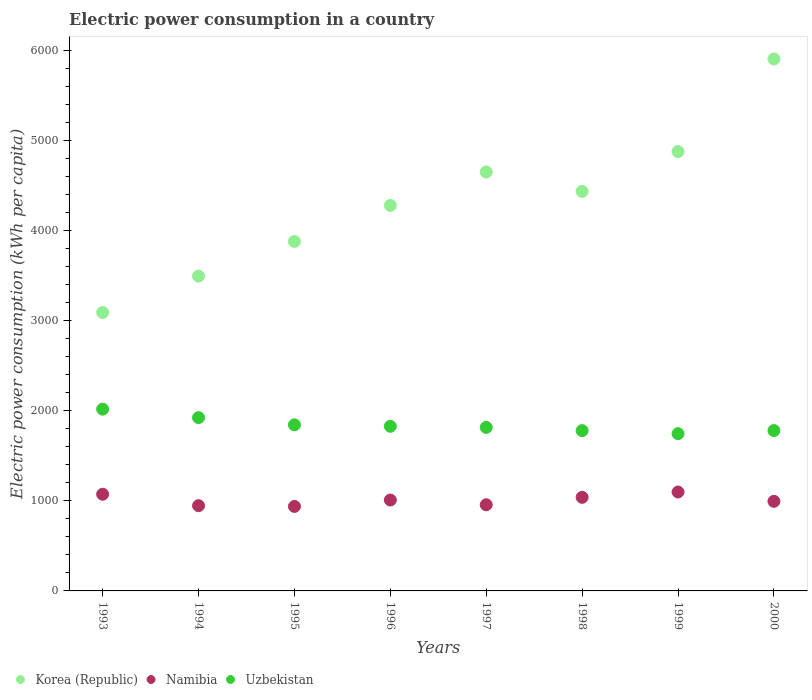Is the number of dotlines equal to the number of legend labels?
Offer a very short reply. Yes. What is the electric power consumption in in Namibia in 1997?
Ensure brevity in your answer.  956.72. Across all years, what is the maximum electric power consumption in in Korea (Republic)?
Provide a short and direct response. 5906.96. Across all years, what is the minimum electric power consumption in in Namibia?
Your response must be concise. 938.21. What is the total electric power consumption in in Namibia in the graph?
Offer a terse response. 8056.48. What is the difference between the electric power consumption in in Korea (Republic) in 1994 and that in 1998?
Your answer should be very brief. -940.69. What is the difference between the electric power consumption in in Uzbekistan in 1994 and the electric power consumption in in Namibia in 1999?
Provide a succinct answer. 826.12. What is the average electric power consumption in in Namibia per year?
Make the answer very short. 1007.06. In the year 1998, what is the difference between the electric power consumption in in Namibia and electric power consumption in in Korea (Republic)?
Make the answer very short. -3396.9. In how many years, is the electric power consumption in in Namibia greater than 600 kWh per capita?
Keep it short and to the point. 8. What is the ratio of the electric power consumption in in Uzbekistan in 1998 to that in 1999?
Your response must be concise. 1.02. What is the difference between the highest and the second highest electric power consumption in in Korea (Republic)?
Provide a short and direct response. 1028.13. What is the difference between the highest and the lowest electric power consumption in in Namibia?
Give a very brief answer. 160.15. In how many years, is the electric power consumption in in Uzbekistan greater than the average electric power consumption in in Uzbekistan taken over all years?
Keep it short and to the point. 3. Is the sum of the electric power consumption in in Uzbekistan in 1993 and 1998 greater than the maximum electric power consumption in in Namibia across all years?
Offer a very short reply. Yes. Is the electric power consumption in in Korea (Republic) strictly greater than the electric power consumption in in Namibia over the years?
Offer a very short reply. Yes. How many dotlines are there?
Your answer should be compact. 3. Where does the legend appear in the graph?
Your answer should be compact. Bottom left. How are the legend labels stacked?
Offer a terse response. Horizontal. What is the title of the graph?
Provide a short and direct response. Electric power consumption in a country. What is the label or title of the Y-axis?
Make the answer very short. Electric power consumption (kWh per capita). What is the Electric power consumption (kWh per capita) in Korea (Republic) in 1993?
Give a very brief answer. 3091.37. What is the Electric power consumption (kWh per capita) in Namibia in 1993?
Make the answer very short. 1073.43. What is the Electric power consumption (kWh per capita) in Uzbekistan in 1993?
Make the answer very short. 2018.23. What is the Electric power consumption (kWh per capita) in Korea (Republic) in 1994?
Your answer should be compact. 3495.49. What is the Electric power consumption (kWh per capita) in Namibia in 1994?
Your answer should be compact. 946.55. What is the Electric power consumption (kWh per capita) in Uzbekistan in 1994?
Make the answer very short. 1924.48. What is the Electric power consumption (kWh per capita) in Korea (Republic) in 1995?
Give a very brief answer. 3881.02. What is the Electric power consumption (kWh per capita) in Namibia in 1995?
Provide a short and direct response. 938.21. What is the Electric power consumption (kWh per capita) of Uzbekistan in 1995?
Offer a terse response. 1844.2. What is the Electric power consumption (kWh per capita) of Korea (Republic) in 1996?
Give a very brief answer. 4280.71. What is the Electric power consumption (kWh per capita) of Namibia in 1996?
Offer a terse response. 1009.18. What is the Electric power consumption (kWh per capita) of Uzbekistan in 1996?
Offer a very short reply. 1827.77. What is the Electric power consumption (kWh per capita) in Korea (Republic) in 1997?
Give a very brief answer. 4651.63. What is the Electric power consumption (kWh per capita) in Namibia in 1997?
Your response must be concise. 956.72. What is the Electric power consumption (kWh per capita) of Uzbekistan in 1997?
Provide a succinct answer. 1815.82. What is the Electric power consumption (kWh per capita) of Korea (Republic) in 1998?
Ensure brevity in your answer.  4436.17. What is the Electric power consumption (kWh per capita) of Namibia in 1998?
Provide a succinct answer. 1039.27. What is the Electric power consumption (kWh per capita) in Uzbekistan in 1998?
Make the answer very short. 1779.88. What is the Electric power consumption (kWh per capita) in Korea (Republic) in 1999?
Offer a terse response. 4878.83. What is the Electric power consumption (kWh per capita) in Namibia in 1999?
Keep it short and to the point. 1098.36. What is the Electric power consumption (kWh per capita) of Uzbekistan in 1999?
Keep it short and to the point. 1745.95. What is the Electric power consumption (kWh per capita) of Korea (Republic) in 2000?
Offer a terse response. 5906.96. What is the Electric power consumption (kWh per capita) of Namibia in 2000?
Offer a terse response. 994.76. What is the Electric power consumption (kWh per capita) in Uzbekistan in 2000?
Ensure brevity in your answer.  1780.46. Across all years, what is the maximum Electric power consumption (kWh per capita) in Korea (Republic)?
Make the answer very short. 5906.96. Across all years, what is the maximum Electric power consumption (kWh per capita) in Namibia?
Offer a very short reply. 1098.36. Across all years, what is the maximum Electric power consumption (kWh per capita) in Uzbekistan?
Offer a very short reply. 2018.23. Across all years, what is the minimum Electric power consumption (kWh per capita) in Korea (Republic)?
Your response must be concise. 3091.37. Across all years, what is the minimum Electric power consumption (kWh per capita) in Namibia?
Make the answer very short. 938.21. Across all years, what is the minimum Electric power consumption (kWh per capita) in Uzbekistan?
Your response must be concise. 1745.95. What is the total Electric power consumption (kWh per capita) in Korea (Republic) in the graph?
Provide a short and direct response. 3.46e+04. What is the total Electric power consumption (kWh per capita) of Namibia in the graph?
Give a very brief answer. 8056.48. What is the total Electric power consumption (kWh per capita) of Uzbekistan in the graph?
Your response must be concise. 1.47e+04. What is the difference between the Electric power consumption (kWh per capita) in Korea (Republic) in 1993 and that in 1994?
Your response must be concise. -404.12. What is the difference between the Electric power consumption (kWh per capita) in Namibia in 1993 and that in 1994?
Offer a terse response. 126.88. What is the difference between the Electric power consumption (kWh per capita) of Uzbekistan in 1993 and that in 1994?
Give a very brief answer. 93.75. What is the difference between the Electric power consumption (kWh per capita) of Korea (Republic) in 1993 and that in 1995?
Your answer should be very brief. -789.65. What is the difference between the Electric power consumption (kWh per capita) in Namibia in 1993 and that in 1995?
Offer a terse response. 135.22. What is the difference between the Electric power consumption (kWh per capita) in Uzbekistan in 1993 and that in 1995?
Make the answer very short. 174.03. What is the difference between the Electric power consumption (kWh per capita) in Korea (Republic) in 1993 and that in 1996?
Offer a terse response. -1189.34. What is the difference between the Electric power consumption (kWh per capita) in Namibia in 1993 and that in 1996?
Offer a very short reply. 64.26. What is the difference between the Electric power consumption (kWh per capita) of Uzbekistan in 1993 and that in 1996?
Offer a very short reply. 190.46. What is the difference between the Electric power consumption (kWh per capita) of Korea (Republic) in 1993 and that in 1997?
Provide a succinct answer. -1560.26. What is the difference between the Electric power consumption (kWh per capita) in Namibia in 1993 and that in 1997?
Offer a terse response. 116.72. What is the difference between the Electric power consumption (kWh per capita) of Uzbekistan in 1993 and that in 1997?
Your answer should be compact. 202.41. What is the difference between the Electric power consumption (kWh per capita) of Korea (Republic) in 1993 and that in 1998?
Your response must be concise. -1344.8. What is the difference between the Electric power consumption (kWh per capita) in Namibia in 1993 and that in 1998?
Provide a short and direct response. 34.16. What is the difference between the Electric power consumption (kWh per capita) of Uzbekistan in 1993 and that in 1998?
Provide a succinct answer. 238.35. What is the difference between the Electric power consumption (kWh per capita) in Korea (Republic) in 1993 and that in 1999?
Give a very brief answer. -1787.46. What is the difference between the Electric power consumption (kWh per capita) in Namibia in 1993 and that in 1999?
Provide a short and direct response. -24.92. What is the difference between the Electric power consumption (kWh per capita) of Uzbekistan in 1993 and that in 1999?
Ensure brevity in your answer.  272.28. What is the difference between the Electric power consumption (kWh per capita) of Korea (Republic) in 1993 and that in 2000?
Provide a short and direct response. -2815.59. What is the difference between the Electric power consumption (kWh per capita) in Namibia in 1993 and that in 2000?
Make the answer very short. 78.68. What is the difference between the Electric power consumption (kWh per capita) in Uzbekistan in 1993 and that in 2000?
Ensure brevity in your answer.  237.77. What is the difference between the Electric power consumption (kWh per capita) in Korea (Republic) in 1994 and that in 1995?
Offer a terse response. -385.54. What is the difference between the Electric power consumption (kWh per capita) of Namibia in 1994 and that in 1995?
Give a very brief answer. 8.34. What is the difference between the Electric power consumption (kWh per capita) of Uzbekistan in 1994 and that in 1995?
Give a very brief answer. 80.28. What is the difference between the Electric power consumption (kWh per capita) in Korea (Republic) in 1994 and that in 1996?
Your response must be concise. -785.22. What is the difference between the Electric power consumption (kWh per capita) of Namibia in 1994 and that in 1996?
Your answer should be compact. -62.63. What is the difference between the Electric power consumption (kWh per capita) of Uzbekistan in 1994 and that in 1996?
Your answer should be very brief. 96.7. What is the difference between the Electric power consumption (kWh per capita) of Korea (Republic) in 1994 and that in 1997?
Ensure brevity in your answer.  -1156.14. What is the difference between the Electric power consumption (kWh per capita) of Namibia in 1994 and that in 1997?
Make the answer very short. -10.16. What is the difference between the Electric power consumption (kWh per capita) in Uzbekistan in 1994 and that in 1997?
Make the answer very short. 108.66. What is the difference between the Electric power consumption (kWh per capita) of Korea (Republic) in 1994 and that in 1998?
Keep it short and to the point. -940.69. What is the difference between the Electric power consumption (kWh per capita) of Namibia in 1994 and that in 1998?
Offer a very short reply. -92.72. What is the difference between the Electric power consumption (kWh per capita) in Uzbekistan in 1994 and that in 1998?
Give a very brief answer. 144.59. What is the difference between the Electric power consumption (kWh per capita) of Korea (Republic) in 1994 and that in 1999?
Offer a very short reply. -1383.34. What is the difference between the Electric power consumption (kWh per capita) in Namibia in 1994 and that in 1999?
Your response must be concise. -151.8. What is the difference between the Electric power consumption (kWh per capita) in Uzbekistan in 1994 and that in 1999?
Provide a short and direct response. 178.52. What is the difference between the Electric power consumption (kWh per capita) in Korea (Republic) in 1994 and that in 2000?
Give a very brief answer. -2411.47. What is the difference between the Electric power consumption (kWh per capita) of Namibia in 1994 and that in 2000?
Give a very brief answer. -48.2. What is the difference between the Electric power consumption (kWh per capita) of Uzbekistan in 1994 and that in 2000?
Offer a terse response. 144.02. What is the difference between the Electric power consumption (kWh per capita) of Korea (Republic) in 1995 and that in 1996?
Your response must be concise. -399.69. What is the difference between the Electric power consumption (kWh per capita) of Namibia in 1995 and that in 1996?
Your response must be concise. -70.97. What is the difference between the Electric power consumption (kWh per capita) in Uzbekistan in 1995 and that in 1996?
Your answer should be very brief. 16.42. What is the difference between the Electric power consumption (kWh per capita) in Korea (Republic) in 1995 and that in 1997?
Provide a short and direct response. -770.6. What is the difference between the Electric power consumption (kWh per capita) of Namibia in 1995 and that in 1997?
Your answer should be compact. -18.51. What is the difference between the Electric power consumption (kWh per capita) in Uzbekistan in 1995 and that in 1997?
Offer a terse response. 28.38. What is the difference between the Electric power consumption (kWh per capita) in Korea (Republic) in 1995 and that in 1998?
Make the answer very short. -555.15. What is the difference between the Electric power consumption (kWh per capita) in Namibia in 1995 and that in 1998?
Your answer should be very brief. -101.06. What is the difference between the Electric power consumption (kWh per capita) in Uzbekistan in 1995 and that in 1998?
Give a very brief answer. 64.31. What is the difference between the Electric power consumption (kWh per capita) in Korea (Republic) in 1995 and that in 1999?
Offer a terse response. -997.81. What is the difference between the Electric power consumption (kWh per capita) in Namibia in 1995 and that in 1999?
Provide a short and direct response. -160.15. What is the difference between the Electric power consumption (kWh per capita) in Uzbekistan in 1995 and that in 1999?
Offer a terse response. 98.24. What is the difference between the Electric power consumption (kWh per capita) in Korea (Republic) in 1995 and that in 2000?
Offer a terse response. -2025.93. What is the difference between the Electric power consumption (kWh per capita) in Namibia in 1995 and that in 2000?
Provide a short and direct response. -56.55. What is the difference between the Electric power consumption (kWh per capita) of Uzbekistan in 1995 and that in 2000?
Ensure brevity in your answer.  63.74. What is the difference between the Electric power consumption (kWh per capita) in Korea (Republic) in 1996 and that in 1997?
Ensure brevity in your answer.  -370.92. What is the difference between the Electric power consumption (kWh per capita) in Namibia in 1996 and that in 1997?
Ensure brevity in your answer.  52.46. What is the difference between the Electric power consumption (kWh per capita) of Uzbekistan in 1996 and that in 1997?
Offer a terse response. 11.95. What is the difference between the Electric power consumption (kWh per capita) of Korea (Republic) in 1996 and that in 1998?
Give a very brief answer. -155.46. What is the difference between the Electric power consumption (kWh per capita) in Namibia in 1996 and that in 1998?
Make the answer very short. -30.09. What is the difference between the Electric power consumption (kWh per capita) of Uzbekistan in 1996 and that in 1998?
Make the answer very short. 47.89. What is the difference between the Electric power consumption (kWh per capita) of Korea (Republic) in 1996 and that in 1999?
Your answer should be compact. -598.12. What is the difference between the Electric power consumption (kWh per capita) of Namibia in 1996 and that in 1999?
Your answer should be very brief. -89.18. What is the difference between the Electric power consumption (kWh per capita) of Uzbekistan in 1996 and that in 1999?
Give a very brief answer. 81.82. What is the difference between the Electric power consumption (kWh per capita) in Korea (Republic) in 1996 and that in 2000?
Give a very brief answer. -1626.25. What is the difference between the Electric power consumption (kWh per capita) in Namibia in 1996 and that in 2000?
Your response must be concise. 14.42. What is the difference between the Electric power consumption (kWh per capita) of Uzbekistan in 1996 and that in 2000?
Provide a short and direct response. 47.31. What is the difference between the Electric power consumption (kWh per capita) in Korea (Republic) in 1997 and that in 1998?
Provide a short and direct response. 215.45. What is the difference between the Electric power consumption (kWh per capita) of Namibia in 1997 and that in 1998?
Offer a very short reply. -82.56. What is the difference between the Electric power consumption (kWh per capita) of Uzbekistan in 1997 and that in 1998?
Ensure brevity in your answer.  35.94. What is the difference between the Electric power consumption (kWh per capita) in Korea (Republic) in 1997 and that in 1999?
Offer a very short reply. -227.2. What is the difference between the Electric power consumption (kWh per capita) in Namibia in 1997 and that in 1999?
Your answer should be compact. -141.64. What is the difference between the Electric power consumption (kWh per capita) in Uzbekistan in 1997 and that in 1999?
Provide a succinct answer. 69.87. What is the difference between the Electric power consumption (kWh per capita) in Korea (Republic) in 1997 and that in 2000?
Provide a short and direct response. -1255.33. What is the difference between the Electric power consumption (kWh per capita) in Namibia in 1997 and that in 2000?
Ensure brevity in your answer.  -38.04. What is the difference between the Electric power consumption (kWh per capita) of Uzbekistan in 1997 and that in 2000?
Provide a succinct answer. 35.36. What is the difference between the Electric power consumption (kWh per capita) in Korea (Republic) in 1998 and that in 1999?
Give a very brief answer. -442.66. What is the difference between the Electric power consumption (kWh per capita) of Namibia in 1998 and that in 1999?
Your answer should be very brief. -59.08. What is the difference between the Electric power consumption (kWh per capita) in Uzbekistan in 1998 and that in 1999?
Ensure brevity in your answer.  33.93. What is the difference between the Electric power consumption (kWh per capita) in Korea (Republic) in 1998 and that in 2000?
Provide a succinct answer. -1470.78. What is the difference between the Electric power consumption (kWh per capita) of Namibia in 1998 and that in 2000?
Your answer should be compact. 44.52. What is the difference between the Electric power consumption (kWh per capita) in Uzbekistan in 1998 and that in 2000?
Provide a succinct answer. -0.57. What is the difference between the Electric power consumption (kWh per capita) of Korea (Republic) in 1999 and that in 2000?
Make the answer very short. -1028.13. What is the difference between the Electric power consumption (kWh per capita) in Namibia in 1999 and that in 2000?
Offer a very short reply. 103.6. What is the difference between the Electric power consumption (kWh per capita) of Uzbekistan in 1999 and that in 2000?
Offer a very short reply. -34.5. What is the difference between the Electric power consumption (kWh per capita) of Korea (Republic) in 1993 and the Electric power consumption (kWh per capita) of Namibia in 1994?
Make the answer very short. 2144.82. What is the difference between the Electric power consumption (kWh per capita) in Korea (Republic) in 1993 and the Electric power consumption (kWh per capita) in Uzbekistan in 1994?
Make the answer very short. 1166.9. What is the difference between the Electric power consumption (kWh per capita) of Namibia in 1993 and the Electric power consumption (kWh per capita) of Uzbekistan in 1994?
Your answer should be compact. -851.04. What is the difference between the Electric power consumption (kWh per capita) in Korea (Republic) in 1993 and the Electric power consumption (kWh per capita) in Namibia in 1995?
Ensure brevity in your answer.  2153.16. What is the difference between the Electric power consumption (kWh per capita) in Korea (Republic) in 1993 and the Electric power consumption (kWh per capita) in Uzbekistan in 1995?
Your answer should be very brief. 1247.18. What is the difference between the Electric power consumption (kWh per capita) of Namibia in 1993 and the Electric power consumption (kWh per capita) of Uzbekistan in 1995?
Your answer should be compact. -770.76. What is the difference between the Electric power consumption (kWh per capita) of Korea (Republic) in 1993 and the Electric power consumption (kWh per capita) of Namibia in 1996?
Your answer should be very brief. 2082.19. What is the difference between the Electric power consumption (kWh per capita) in Korea (Republic) in 1993 and the Electric power consumption (kWh per capita) in Uzbekistan in 1996?
Keep it short and to the point. 1263.6. What is the difference between the Electric power consumption (kWh per capita) in Namibia in 1993 and the Electric power consumption (kWh per capita) in Uzbekistan in 1996?
Your answer should be very brief. -754.34. What is the difference between the Electric power consumption (kWh per capita) of Korea (Republic) in 1993 and the Electric power consumption (kWh per capita) of Namibia in 1997?
Keep it short and to the point. 2134.65. What is the difference between the Electric power consumption (kWh per capita) in Korea (Republic) in 1993 and the Electric power consumption (kWh per capita) in Uzbekistan in 1997?
Make the answer very short. 1275.55. What is the difference between the Electric power consumption (kWh per capita) in Namibia in 1993 and the Electric power consumption (kWh per capita) in Uzbekistan in 1997?
Offer a very short reply. -742.38. What is the difference between the Electric power consumption (kWh per capita) in Korea (Republic) in 1993 and the Electric power consumption (kWh per capita) in Namibia in 1998?
Make the answer very short. 2052.1. What is the difference between the Electric power consumption (kWh per capita) in Korea (Republic) in 1993 and the Electric power consumption (kWh per capita) in Uzbekistan in 1998?
Your answer should be very brief. 1311.49. What is the difference between the Electric power consumption (kWh per capita) in Namibia in 1993 and the Electric power consumption (kWh per capita) in Uzbekistan in 1998?
Make the answer very short. -706.45. What is the difference between the Electric power consumption (kWh per capita) of Korea (Republic) in 1993 and the Electric power consumption (kWh per capita) of Namibia in 1999?
Ensure brevity in your answer.  1993.01. What is the difference between the Electric power consumption (kWh per capita) of Korea (Republic) in 1993 and the Electric power consumption (kWh per capita) of Uzbekistan in 1999?
Your answer should be very brief. 1345.42. What is the difference between the Electric power consumption (kWh per capita) of Namibia in 1993 and the Electric power consumption (kWh per capita) of Uzbekistan in 1999?
Offer a terse response. -672.52. What is the difference between the Electric power consumption (kWh per capita) of Korea (Republic) in 1993 and the Electric power consumption (kWh per capita) of Namibia in 2000?
Make the answer very short. 2096.62. What is the difference between the Electric power consumption (kWh per capita) in Korea (Republic) in 1993 and the Electric power consumption (kWh per capita) in Uzbekistan in 2000?
Provide a succinct answer. 1310.91. What is the difference between the Electric power consumption (kWh per capita) in Namibia in 1993 and the Electric power consumption (kWh per capita) in Uzbekistan in 2000?
Offer a terse response. -707.02. What is the difference between the Electric power consumption (kWh per capita) in Korea (Republic) in 1994 and the Electric power consumption (kWh per capita) in Namibia in 1995?
Provide a short and direct response. 2557.28. What is the difference between the Electric power consumption (kWh per capita) in Korea (Republic) in 1994 and the Electric power consumption (kWh per capita) in Uzbekistan in 1995?
Make the answer very short. 1651.29. What is the difference between the Electric power consumption (kWh per capita) of Namibia in 1994 and the Electric power consumption (kWh per capita) of Uzbekistan in 1995?
Ensure brevity in your answer.  -897.64. What is the difference between the Electric power consumption (kWh per capita) in Korea (Republic) in 1994 and the Electric power consumption (kWh per capita) in Namibia in 1996?
Give a very brief answer. 2486.31. What is the difference between the Electric power consumption (kWh per capita) of Korea (Republic) in 1994 and the Electric power consumption (kWh per capita) of Uzbekistan in 1996?
Your answer should be compact. 1667.72. What is the difference between the Electric power consumption (kWh per capita) in Namibia in 1994 and the Electric power consumption (kWh per capita) in Uzbekistan in 1996?
Your response must be concise. -881.22. What is the difference between the Electric power consumption (kWh per capita) of Korea (Republic) in 1994 and the Electric power consumption (kWh per capita) of Namibia in 1997?
Make the answer very short. 2538.77. What is the difference between the Electric power consumption (kWh per capita) in Korea (Republic) in 1994 and the Electric power consumption (kWh per capita) in Uzbekistan in 1997?
Keep it short and to the point. 1679.67. What is the difference between the Electric power consumption (kWh per capita) in Namibia in 1994 and the Electric power consumption (kWh per capita) in Uzbekistan in 1997?
Provide a short and direct response. -869.27. What is the difference between the Electric power consumption (kWh per capita) in Korea (Republic) in 1994 and the Electric power consumption (kWh per capita) in Namibia in 1998?
Give a very brief answer. 2456.22. What is the difference between the Electric power consumption (kWh per capita) in Korea (Republic) in 1994 and the Electric power consumption (kWh per capita) in Uzbekistan in 1998?
Ensure brevity in your answer.  1715.6. What is the difference between the Electric power consumption (kWh per capita) of Namibia in 1994 and the Electric power consumption (kWh per capita) of Uzbekistan in 1998?
Your response must be concise. -833.33. What is the difference between the Electric power consumption (kWh per capita) in Korea (Republic) in 1994 and the Electric power consumption (kWh per capita) in Namibia in 1999?
Make the answer very short. 2397.13. What is the difference between the Electric power consumption (kWh per capita) in Korea (Republic) in 1994 and the Electric power consumption (kWh per capita) in Uzbekistan in 1999?
Make the answer very short. 1749.54. What is the difference between the Electric power consumption (kWh per capita) in Namibia in 1994 and the Electric power consumption (kWh per capita) in Uzbekistan in 1999?
Make the answer very short. -799.4. What is the difference between the Electric power consumption (kWh per capita) of Korea (Republic) in 1994 and the Electric power consumption (kWh per capita) of Namibia in 2000?
Your response must be concise. 2500.73. What is the difference between the Electric power consumption (kWh per capita) of Korea (Republic) in 1994 and the Electric power consumption (kWh per capita) of Uzbekistan in 2000?
Your answer should be compact. 1715.03. What is the difference between the Electric power consumption (kWh per capita) of Namibia in 1994 and the Electric power consumption (kWh per capita) of Uzbekistan in 2000?
Your answer should be compact. -833.91. What is the difference between the Electric power consumption (kWh per capita) of Korea (Republic) in 1995 and the Electric power consumption (kWh per capita) of Namibia in 1996?
Your response must be concise. 2871.85. What is the difference between the Electric power consumption (kWh per capita) in Korea (Republic) in 1995 and the Electric power consumption (kWh per capita) in Uzbekistan in 1996?
Offer a very short reply. 2053.25. What is the difference between the Electric power consumption (kWh per capita) in Namibia in 1995 and the Electric power consumption (kWh per capita) in Uzbekistan in 1996?
Provide a short and direct response. -889.56. What is the difference between the Electric power consumption (kWh per capita) of Korea (Republic) in 1995 and the Electric power consumption (kWh per capita) of Namibia in 1997?
Offer a very short reply. 2924.31. What is the difference between the Electric power consumption (kWh per capita) in Korea (Republic) in 1995 and the Electric power consumption (kWh per capita) in Uzbekistan in 1997?
Provide a short and direct response. 2065.2. What is the difference between the Electric power consumption (kWh per capita) in Namibia in 1995 and the Electric power consumption (kWh per capita) in Uzbekistan in 1997?
Make the answer very short. -877.61. What is the difference between the Electric power consumption (kWh per capita) of Korea (Republic) in 1995 and the Electric power consumption (kWh per capita) of Namibia in 1998?
Provide a short and direct response. 2841.75. What is the difference between the Electric power consumption (kWh per capita) in Korea (Republic) in 1995 and the Electric power consumption (kWh per capita) in Uzbekistan in 1998?
Keep it short and to the point. 2101.14. What is the difference between the Electric power consumption (kWh per capita) in Namibia in 1995 and the Electric power consumption (kWh per capita) in Uzbekistan in 1998?
Provide a succinct answer. -841.67. What is the difference between the Electric power consumption (kWh per capita) in Korea (Republic) in 1995 and the Electric power consumption (kWh per capita) in Namibia in 1999?
Keep it short and to the point. 2782.67. What is the difference between the Electric power consumption (kWh per capita) in Korea (Republic) in 1995 and the Electric power consumption (kWh per capita) in Uzbekistan in 1999?
Keep it short and to the point. 2135.07. What is the difference between the Electric power consumption (kWh per capita) of Namibia in 1995 and the Electric power consumption (kWh per capita) of Uzbekistan in 1999?
Offer a very short reply. -807.74. What is the difference between the Electric power consumption (kWh per capita) in Korea (Republic) in 1995 and the Electric power consumption (kWh per capita) in Namibia in 2000?
Keep it short and to the point. 2886.27. What is the difference between the Electric power consumption (kWh per capita) in Korea (Republic) in 1995 and the Electric power consumption (kWh per capita) in Uzbekistan in 2000?
Offer a terse response. 2100.57. What is the difference between the Electric power consumption (kWh per capita) of Namibia in 1995 and the Electric power consumption (kWh per capita) of Uzbekistan in 2000?
Offer a terse response. -842.25. What is the difference between the Electric power consumption (kWh per capita) in Korea (Republic) in 1996 and the Electric power consumption (kWh per capita) in Namibia in 1997?
Make the answer very short. 3323.99. What is the difference between the Electric power consumption (kWh per capita) in Korea (Republic) in 1996 and the Electric power consumption (kWh per capita) in Uzbekistan in 1997?
Provide a short and direct response. 2464.89. What is the difference between the Electric power consumption (kWh per capita) in Namibia in 1996 and the Electric power consumption (kWh per capita) in Uzbekistan in 1997?
Keep it short and to the point. -806.64. What is the difference between the Electric power consumption (kWh per capita) of Korea (Republic) in 1996 and the Electric power consumption (kWh per capita) of Namibia in 1998?
Ensure brevity in your answer.  3241.44. What is the difference between the Electric power consumption (kWh per capita) of Korea (Republic) in 1996 and the Electric power consumption (kWh per capita) of Uzbekistan in 1998?
Offer a terse response. 2500.83. What is the difference between the Electric power consumption (kWh per capita) in Namibia in 1996 and the Electric power consumption (kWh per capita) in Uzbekistan in 1998?
Give a very brief answer. -770.71. What is the difference between the Electric power consumption (kWh per capita) in Korea (Republic) in 1996 and the Electric power consumption (kWh per capita) in Namibia in 1999?
Provide a short and direct response. 3182.35. What is the difference between the Electric power consumption (kWh per capita) in Korea (Republic) in 1996 and the Electric power consumption (kWh per capita) in Uzbekistan in 1999?
Give a very brief answer. 2534.76. What is the difference between the Electric power consumption (kWh per capita) in Namibia in 1996 and the Electric power consumption (kWh per capita) in Uzbekistan in 1999?
Make the answer very short. -736.78. What is the difference between the Electric power consumption (kWh per capita) of Korea (Republic) in 1996 and the Electric power consumption (kWh per capita) of Namibia in 2000?
Your answer should be compact. 3285.95. What is the difference between the Electric power consumption (kWh per capita) in Korea (Republic) in 1996 and the Electric power consumption (kWh per capita) in Uzbekistan in 2000?
Provide a short and direct response. 2500.25. What is the difference between the Electric power consumption (kWh per capita) of Namibia in 1996 and the Electric power consumption (kWh per capita) of Uzbekistan in 2000?
Offer a very short reply. -771.28. What is the difference between the Electric power consumption (kWh per capita) in Korea (Republic) in 1997 and the Electric power consumption (kWh per capita) in Namibia in 1998?
Make the answer very short. 3612.36. What is the difference between the Electric power consumption (kWh per capita) of Korea (Republic) in 1997 and the Electric power consumption (kWh per capita) of Uzbekistan in 1998?
Your answer should be compact. 2871.74. What is the difference between the Electric power consumption (kWh per capita) of Namibia in 1997 and the Electric power consumption (kWh per capita) of Uzbekistan in 1998?
Your answer should be compact. -823.17. What is the difference between the Electric power consumption (kWh per capita) of Korea (Republic) in 1997 and the Electric power consumption (kWh per capita) of Namibia in 1999?
Make the answer very short. 3553.27. What is the difference between the Electric power consumption (kWh per capita) in Korea (Republic) in 1997 and the Electric power consumption (kWh per capita) in Uzbekistan in 1999?
Your answer should be very brief. 2905.68. What is the difference between the Electric power consumption (kWh per capita) in Namibia in 1997 and the Electric power consumption (kWh per capita) in Uzbekistan in 1999?
Make the answer very short. -789.24. What is the difference between the Electric power consumption (kWh per capita) in Korea (Republic) in 1997 and the Electric power consumption (kWh per capita) in Namibia in 2000?
Make the answer very short. 3656.87. What is the difference between the Electric power consumption (kWh per capita) in Korea (Republic) in 1997 and the Electric power consumption (kWh per capita) in Uzbekistan in 2000?
Offer a very short reply. 2871.17. What is the difference between the Electric power consumption (kWh per capita) in Namibia in 1997 and the Electric power consumption (kWh per capita) in Uzbekistan in 2000?
Offer a very short reply. -823.74. What is the difference between the Electric power consumption (kWh per capita) of Korea (Republic) in 1998 and the Electric power consumption (kWh per capita) of Namibia in 1999?
Make the answer very short. 3337.82. What is the difference between the Electric power consumption (kWh per capita) in Korea (Republic) in 1998 and the Electric power consumption (kWh per capita) in Uzbekistan in 1999?
Make the answer very short. 2690.22. What is the difference between the Electric power consumption (kWh per capita) in Namibia in 1998 and the Electric power consumption (kWh per capita) in Uzbekistan in 1999?
Your answer should be very brief. -706.68. What is the difference between the Electric power consumption (kWh per capita) of Korea (Republic) in 1998 and the Electric power consumption (kWh per capita) of Namibia in 2000?
Ensure brevity in your answer.  3441.42. What is the difference between the Electric power consumption (kWh per capita) of Korea (Republic) in 1998 and the Electric power consumption (kWh per capita) of Uzbekistan in 2000?
Provide a short and direct response. 2655.72. What is the difference between the Electric power consumption (kWh per capita) in Namibia in 1998 and the Electric power consumption (kWh per capita) in Uzbekistan in 2000?
Offer a very short reply. -741.19. What is the difference between the Electric power consumption (kWh per capita) in Korea (Republic) in 1999 and the Electric power consumption (kWh per capita) in Namibia in 2000?
Offer a terse response. 3884.08. What is the difference between the Electric power consumption (kWh per capita) of Korea (Republic) in 1999 and the Electric power consumption (kWh per capita) of Uzbekistan in 2000?
Ensure brevity in your answer.  3098.38. What is the difference between the Electric power consumption (kWh per capita) in Namibia in 1999 and the Electric power consumption (kWh per capita) in Uzbekistan in 2000?
Offer a very short reply. -682.1. What is the average Electric power consumption (kWh per capita) in Korea (Republic) per year?
Ensure brevity in your answer.  4327.77. What is the average Electric power consumption (kWh per capita) of Namibia per year?
Offer a very short reply. 1007.06. What is the average Electric power consumption (kWh per capita) of Uzbekistan per year?
Offer a very short reply. 1842.1. In the year 1993, what is the difference between the Electric power consumption (kWh per capita) of Korea (Republic) and Electric power consumption (kWh per capita) of Namibia?
Provide a short and direct response. 2017.94. In the year 1993, what is the difference between the Electric power consumption (kWh per capita) in Korea (Republic) and Electric power consumption (kWh per capita) in Uzbekistan?
Make the answer very short. 1073.14. In the year 1993, what is the difference between the Electric power consumption (kWh per capita) of Namibia and Electric power consumption (kWh per capita) of Uzbekistan?
Give a very brief answer. -944.8. In the year 1994, what is the difference between the Electric power consumption (kWh per capita) in Korea (Republic) and Electric power consumption (kWh per capita) in Namibia?
Your answer should be very brief. 2548.94. In the year 1994, what is the difference between the Electric power consumption (kWh per capita) in Korea (Republic) and Electric power consumption (kWh per capita) in Uzbekistan?
Ensure brevity in your answer.  1571.01. In the year 1994, what is the difference between the Electric power consumption (kWh per capita) of Namibia and Electric power consumption (kWh per capita) of Uzbekistan?
Keep it short and to the point. -977.92. In the year 1995, what is the difference between the Electric power consumption (kWh per capita) of Korea (Republic) and Electric power consumption (kWh per capita) of Namibia?
Your answer should be compact. 2942.81. In the year 1995, what is the difference between the Electric power consumption (kWh per capita) in Korea (Republic) and Electric power consumption (kWh per capita) in Uzbekistan?
Provide a short and direct response. 2036.83. In the year 1995, what is the difference between the Electric power consumption (kWh per capita) of Namibia and Electric power consumption (kWh per capita) of Uzbekistan?
Your response must be concise. -905.99. In the year 1996, what is the difference between the Electric power consumption (kWh per capita) of Korea (Republic) and Electric power consumption (kWh per capita) of Namibia?
Provide a short and direct response. 3271.53. In the year 1996, what is the difference between the Electric power consumption (kWh per capita) in Korea (Republic) and Electric power consumption (kWh per capita) in Uzbekistan?
Provide a succinct answer. 2452.94. In the year 1996, what is the difference between the Electric power consumption (kWh per capita) of Namibia and Electric power consumption (kWh per capita) of Uzbekistan?
Give a very brief answer. -818.59. In the year 1997, what is the difference between the Electric power consumption (kWh per capita) of Korea (Republic) and Electric power consumption (kWh per capita) of Namibia?
Provide a succinct answer. 3694.91. In the year 1997, what is the difference between the Electric power consumption (kWh per capita) in Korea (Republic) and Electric power consumption (kWh per capita) in Uzbekistan?
Provide a short and direct response. 2835.81. In the year 1997, what is the difference between the Electric power consumption (kWh per capita) in Namibia and Electric power consumption (kWh per capita) in Uzbekistan?
Provide a short and direct response. -859.1. In the year 1998, what is the difference between the Electric power consumption (kWh per capita) of Korea (Republic) and Electric power consumption (kWh per capita) of Namibia?
Offer a very short reply. 3396.9. In the year 1998, what is the difference between the Electric power consumption (kWh per capita) of Korea (Republic) and Electric power consumption (kWh per capita) of Uzbekistan?
Your answer should be very brief. 2656.29. In the year 1998, what is the difference between the Electric power consumption (kWh per capita) of Namibia and Electric power consumption (kWh per capita) of Uzbekistan?
Ensure brevity in your answer.  -740.61. In the year 1999, what is the difference between the Electric power consumption (kWh per capita) in Korea (Republic) and Electric power consumption (kWh per capita) in Namibia?
Ensure brevity in your answer.  3780.48. In the year 1999, what is the difference between the Electric power consumption (kWh per capita) of Korea (Republic) and Electric power consumption (kWh per capita) of Uzbekistan?
Your answer should be very brief. 3132.88. In the year 1999, what is the difference between the Electric power consumption (kWh per capita) of Namibia and Electric power consumption (kWh per capita) of Uzbekistan?
Provide a succinct answer. -647.6. In the year 2000, what is the difference between the Electric power consumption (kWh per capita) of Korea (Republic) and Electric power consumption (kWh per capita) of Namibia?
Your response must be concise. 4912.2. In the year 2000, what is the difference between the Electric power consumption (kWh per capita) in Korea (Republic) and Electric power consumption (kWh per capita) in Uzbekistan?
Keep it short and to the point. 4126.5. In the year 2000, what is the difference between the Electric power consumption (kWh per capita) of Namibia and Electric power consumption (kWh per capita) of Uzbekistan?
Provide a short and direct response. -785.7. What is the ratio of the Electric power consumption (kWh per capita) of Korea (Republic) in 1993 to that in 1994?
Ensure brevity in your answer.  0.88. What is the ratio of the Electric power consumption (kWh per capita) of Namibia in 1993 to that in 1994?
Offer a very short reply. 1.13. What is the ratio of the Electric power consumption (kWh per capita) of Uzbekistan in 1993 to that in 1994?
Your answer should be very brief. 1.05. What is the ratio of the Electric power consumption (kWh per capita) of Korea (Republic) in 1993 to that in 1995?
Your answer should be very brief. 0.8. What is the ratio of the Electric power consumption (kWh per capita) of Namibia in 1993 to that in 1995?
Offer a terse response. 1.14. What is the ratio of the Electric power consumption (kWh per capita) of Uzbekistan in 1993 to that in 1995?
Your answer should be very brief. 1.09. What is the ratio of the Electric power consumption (kWh per capita) of Korea (Republic) in 1993 to that in 1996?
Your answer should be compact. 0.72. What is the ratio of the Electric power consumption (kWh per capita) of Namibia in 1993 to that in 1996?
Keep it short and to the point. 1.06. What is the ratio of the Electric power consumption (kWh per capita) of Uzbekistan in 1993 to that in 1996?
Give a very brief answer. 1.1. What is the ratio of the Electric power consumption (kWh per capita) in Korea (Republic) in 1993 to that in 1997?
Provide a succinct answer. 0.66. What is the ratio of the Electric power consumption (kWh per capita) of Namibia in 1993 to that in 1997?
Ensure brevity in your answer.  1.12. What is the ratio of the Electric power consumption (kWh per capita) in Uzbekistan in 1993 to that in 1997?
Ensure brevity in your answer.  1.11. What is the ratio of the Electric power consumption (kWh per capita) in Korea (Republic) in 1993 to that in 1998?
Make the answer very short. 0.7. What is the ratio of the Electric power consumption (kWh per capita) of Namibia in 1993 to that in 1998?
Give a very brief answer. 1.03. What is the ratio of the Electric power consumption (kWh per capita) in Uzbekistan in 1993 to that in 1998?
Ensure brevity in your answer.  1.13. What is the ratio of the Electric power consumption (kWh per capita) in Korea (Republic) in 1993 to that in 1999?
Offer a very short reply. 0.63. What is the ratio of the Electric power consumption (kWh per capita) in Namibia in 1993 to that in 1999?
Offer a terse response. 0.98. What is the ratio of the Electric power consumption (kWh per capita) in Uzbekistan in 1993 to that in 1999?
Your answer should be compact. 1.16. What is the ratio of the Electric power consumption (kWh per capita) of Korea (Republic) in 1993 to that in 2000?
Your answer should be very brief. 0.52. What is the ratio of the Electric power consumption (kWh per capita) of Namibia in 1993 to that in 2000?
Provide a short and direct response. 1.08. What is the ratio of the Electric power consumption (kWh per capita) in Uzbekistan in 1993 to that in 2000?
Your answer should be compact. 1.13. What is the ratio of the Electric power consumption (kWh per capita) in Korea (Republic) in 1994 to that in 1995?
Your answer should be very brief. 0.9. What is the ratio of the Electric power consumption (kWh per capita) of Namibia in 1994 to that in 1995?
Offer a terse response. 1.01. What is the ratio of the Electric power consumption (kWh per capita) of Uzbekistan in 1994 to that in 1995?
Ensure brevity in your answer.  1.04. What is the ratio of the Electric power consumption (kWh per capita) of Korea (Republic) in 1994 to that in 1996?
Your answer should be very brief. 0.82. What is the ratio of the Electric power consumption (kWh per capita) of Namibia in 1994 to that in 1996?
Provide a succinct answer. 0.94. What is the ratio of the Electric power consumption (kWh per capita) in Uzbekistan in 1994 to that in 1996?
Your answer should be very brief. 1.05. What is the ratio of the Electric power consumption (kWh per capita) in Korea (Republic) in 1994 to that in 1997?
Give a very brief answer. 0.75. What is the ratio of the Electric power consumption (kWh per capita) in Namibia in 1994 to that in 1997?
Make the answer very short. 0.99. What is the ratio of the Electric power consumption (kWh per capita) of Uzbekistan in 1994 to that in 1997?
Offer a very short reply. 1.06. What is the ratio of the Electric power consumption (kWh per capita) of Korea (Republic) in 1994 to that in 1998?
Keep it short and to the point. 0.79. What is the ratio of the Electric power consumption (kWh per capita) of Namibia in 1994 to that in 1998?
Your response must be concise. 0.91. What is the ratio of the Electric power consumption (kWh per capita) of Uzbekistan in 1994 to that in 1998?
Offer a terse response. 1.08. What is the ratio of the Electric power consumption (kWh per capita) in Korea (Republic) in 1994 to that in 1999?
Your answer should be very brief. 0.72. What is the ratio of the Electric power consumption (kWh per capita) in Namibia in 1994 to that in 1999?
Offer a terse response. 0.86. What is the ratio of the Electric power consumption (kWh per capita) in Uzbekistan in 1994 to that in 1999?
Provide a short and direct response. 1.1. What is the ratio of the Electric power consumption (kWh per capita) in Korea (Republic) in 1994 to that in 2000?
Give a very brief answer. 0.59. What is the ratio of the Electric power consumption (kWh per capita) of Namibia in 1994 to that in 2000?
Keep it short and to the point. 0.95. What is the ratio of the Electric power consumption (kWh per capita) in Uzbekistan in 1994 to that in 2000?
Your answer should be compact. 1.08. What is the ratio of the Electric power consumption (kWh per capita) in Korea (Republic) in 1995 to that in 1996?
Offer a very short reply. 0.91. What is the ratio of the Electric power consumption (kWh per capita) of Namibia in 1995 to that in 1996?
Make the answer very short. 0.93. What is the ratio of the Electric power consumption (kWh per capita) in Korea (Republic) in 1995 to that in 1997?
Your answer should be compact. 0.83. What is the ratio of the Electric power consumption (kWh per capita) in Namibia in 1995 to that in 1997?
Give a very brief answer. 0.98. What is the ratio of the Electric power consumption (kWh per capita) of Uzbekistan in 1995 to that in 1997?
Offer a very short reply. 1.02. What is the ratio of the Electric power consumption (kWh per capita) in Korea (Republic) in 1995 to that in 1998?
Ensure brevity in your answer.  0.87. What is the ratio of the Electric power consumption (kWh per capita) in Namibia in 1995 to that in 1998?
Provide a short and direct response. 0.9. What is the ratio of the Electric power consumption (kWh per capita) of Uzbekistan in 1995 to that in 1998?
Your answer should be very brief. 1.04. What is the ratio of the Electric power consumption (kWh per capita) of Korea (Republic) in 1995 to that in 1999?
Give a very brief answer. 0.8. What is the ratio of the Electric power consumption (kWh per capita) in Namibia in 1995 to that in 1999?
Offer a very short reply. 0.85. What is the ratio of the Electric power consumption (kWh per capita) in Uzbekistan in 1995 to that in 1999?
Offer a very short reply. 1.06. What is the ratio of the Electric power consumption (kWh per capita) in Korea (Republic) in 1995 to that in 2000?
Offer a terse response. 0.66. What is the ratio of the Electric power consumption (kWh per capita) in Namibia in 1995 to that in 2000?
Offer a terse response. 0.94. What is the ratio of the Electric power consumption (kWh per capita) in Uzbekistan in 1995 to that in 2000?
Your response must be concise. 1.04. What is the ratio of the Electric power consumption (kWh per capita) of Korea (Republic) in 1996 to that in 1997?
Give a very brief answer. 0.92. What is the ratio of the Electric power consumption (kWh per capita) in Namibia in 1996 to that in 1997?
Ensure brevity in your answer.  1.05. What is the ratio of the Electric power consumption (kWh per capita) in Uzbekistan in 1996 to that in 1997?
Offer a very short reply. 1.01. What is the ratio of the Electric power consumption (kWh per capita) in Namibia in 1996 to that in 1998?
Keep it short and to the point. 0.97. What is the ratio of the Electric power consumption (kWh per capita) of Uzbekistan in 1996 to that in 1998?
Make the answer very short. 1.03. What is the ratio of the Electric power consumption (kWh per capita) of Korea (Republic) in 1996 to that in 1999?
Ensure brevity in your answer.  0.88. What is the ratio of the Electric power consumption (kWh per capita) of Namibia in 1996 to that in 1999?
Offer a very short reply. 0.92. What is the ratio of the Electric power consumption (kWh per capita) of Uzbekistan in 1996 to that in 1999?
Provide a succinct answer. 1.05. What is the ratio of the Electric power consumption (kWh per capita) of Korea (Republic) in 1996 to that in 2000?
Your answer should be very brief. 0.72. What is the ratio of the Electric power consumption (kWh per capita) of Namibia in 1996 to that in 2000?
Provide a short and direct response. 1.01. What is the ratio of the Electric power consumption (kWh per capita) of Uzbekistan in 1996 to that in 2000?
Your answer should be compact. 1.03. What is the ratio of the Electric power consumption (kWh per capita) in Korea (Republic) in 1997 to that in 1998?
Ensure brevity in your answer.  1.05. What is the ratio of the Electric power consumption (kWh per capita) of Namibia in 1997 to that in 1998?
Offer a very short reply. 0.92. What is the ratio of the Electric power consumption (kWh per capita) of Uzbekistan in 1997 to that in 1998?
Make the answer very short. 1.02. What is the ratio of the Electric power consumption (kWh per capita) of Korea (Republic) in 1997 to that in 1999?
Provide a short and direct response. 0.95. What is the ratio of the Electric power consumption (kWh per capita) of Namibia in 1997 to that in 1999?
Provide a succinct answer. 0.87. What is the ratio of the Electric power consumption (kWh per capita) in Uzbekistan in 1997 to that in 1999?
Keep it short and to the point. 1.04. What is the ratio of the Electric power consumption (kWh per capita) of Korea (Republic) in 1997 to that in 2000?
Provide a succinct answer. 0.79. What is the ratio of the Electric power consumption (kWh per capita) in Namibia in 1997 to that in 2000?
Offer a terse response. 0.96. What is the ratio of the Electric power consumption (kWh per capita) in Uzbekistan in 1997 to that in 2000?
Offer a very short reply. 1.02. What is the ratio of the Electric power consumption (kWh per capita) in Korea (Republic) in 1998 to that in 1999?
Your response must be concise. 0.91. What is the ratio of the Electric power consumption (kWh per capita) in Namibia in 1998 to that in 1999?
Provide a succinct answer. 0.95. What is the ratio of the Electric power consumption (kWh per capita) of Uzbekistan in 1998 to that in 1999?
Keep it short and to the point. 1.02. What is the ratio of the Electric power consumption (kWh per capita) in Korea (Republic) in 1998 to that in 2000?
Offer a terse response. 0.75. What is the ratio of the Electric power consumption (kWh per capita) in Namibia in 1998 to that in 2000?
Give a very brief answer. 1.04. What is the ratio of the Electric power consumption (kWh per capita) in Uzbekistan in 1998 to that in 2000?
Your answer should be compact. 1. What is the ratio of the Electric power consumption (kWh per capita) in Korea (Republic) in 1999 to that in 2000?
Your answer should be compact. 0.83. What is the ratio of the Electric power consumption (kWh per capita) in Namibia in 1999 to that in 2000?
Ensure brevity in your answer.  1.1. What is the ratio of the Electric power consumption (kWh per capita) in Uzbekistan in 1999 to that in 2000?
Give a very brief answer. 0.98. What is the difference between the highest and the second highest Electric power consumption (kWh per capita) in Korea (Republic)?
Your answer should be compact. 1028.13. What is the difference between the highest and the second highest Electric power consumption (kWh per capita) of Namibia?
Give a very brief answer. 24.92. What is the difference between the highest and the second highest Electric power consumption (kWh per capita) in Uzbekistan?
Provide a short and direct response. 93.75. What is the difference between the highest and the lowest Electric power consumption (kWh per capita) of Korea (Republic)?
Keep it short and to the point. 2815.59. What is the difference between the highest and the lowest Electric power consumption (kWh per capita) of Namibia?
Provide a succinct answer. 160.15. What is the difference between the highest and the lowest Electric power consumption (kWh per capita) in Uzbekistan?
Make the answer very short. 272.28. 